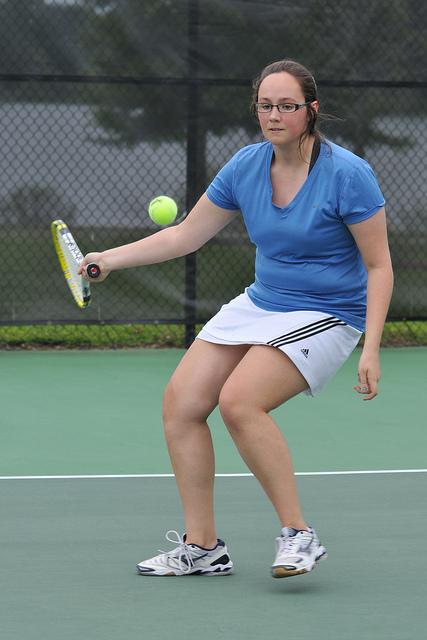Is she ready to serve?
Short answer required. No. What's on the wrist?
Be succinct. Nothing. Is the woman trying to return a ball that went right to her?
Concise answer only. Yes. Is the player sweating?
Be succinct. No. Which hand does the tennis player write with?
Quick response, please. Right. Is she wearing a tank top?
Short answer required. No. Does this lady have long legs?
Write a very short answer. No. What brand shoes is the player wearing?
Quick response, please. Nike. Is it a sunny day?
Concise answer only. Yes. Is she dancing?
Concise answer only. No. Is she wearing a white tee shirt?
Quick response, please. No. What is in the girl's ears?
Keep it brief. Nothing. 